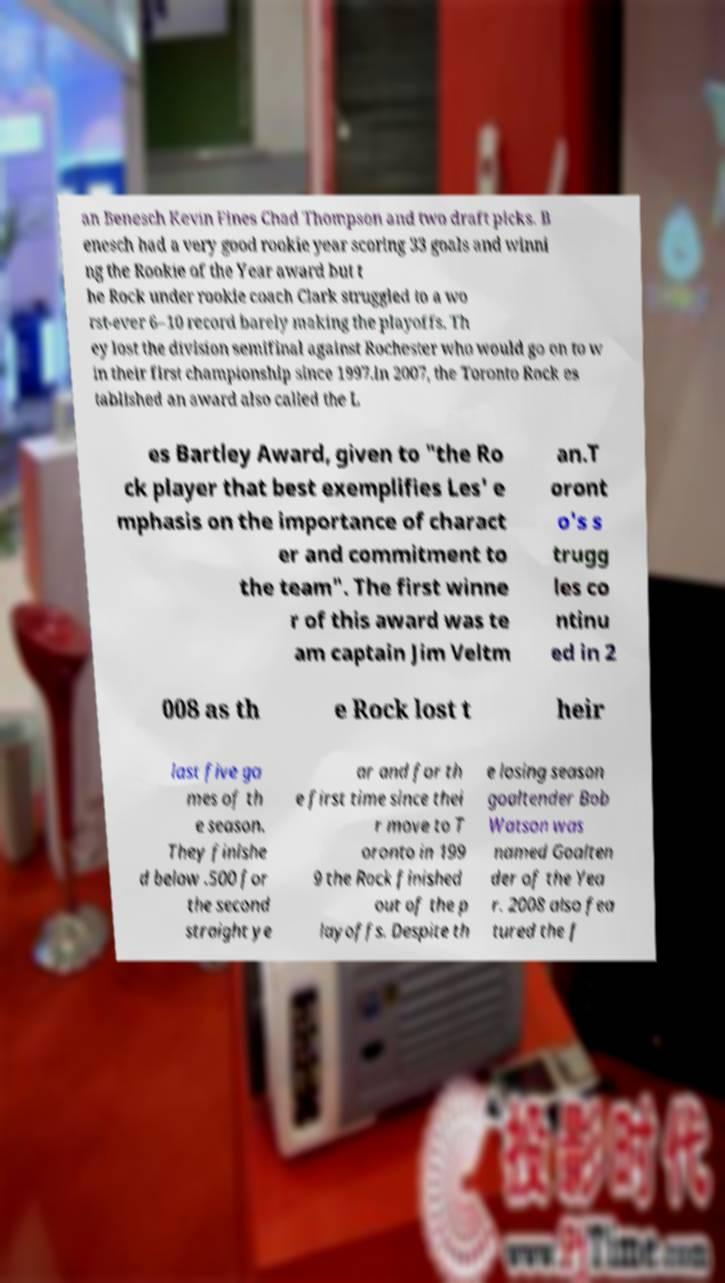For documentation purposes, I need the text within this image transcribed. Could you provide that? an Benesch Kevin Fines Chad Thompson and two draft picks. B enesch had a very good rookie year scoring 33 goals and winni ng the Rookie of the Year award but t he Rock under rookie coach Clark struggled to a wo rst-ever 6–10 record barely making the playoffs. Th ey lost the division semifinal against Rochester who would go on to w in their first championship since 1997.In 2007, the Toronto Rock es tablished an award also called the L es Bartley Award, given to "the Ro ck player that best exemplifies Les' e mphasis on the importance of charact er and commitment to the team". The first winne r of this award was te am captain Jim Veltm an.T oront o's s trugg les co ntinu ed in 2 008 as th e Rock lost t heir last five ga mes of th e season. They finishe d below .500 for the second straight ye ar and for th e first time since thei r move to T oronto in 199 9 the Rock finished out of the p layoffs. Despite th e losing season goaltender Bob Watson was named Goalten der of the Yea r. 2008 also fea tured the f 